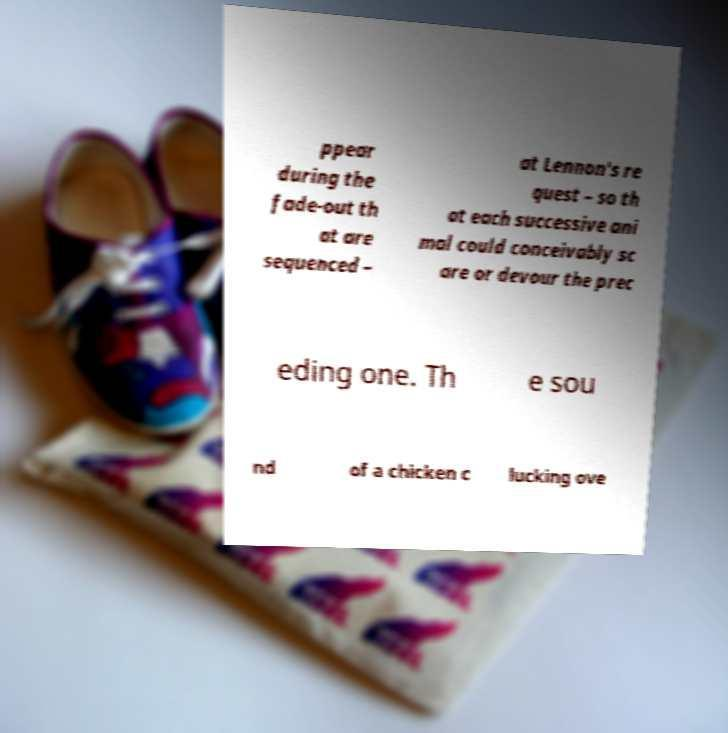For documentation purposes, I need the text within this image transcribed. Could you provide that? ppear during the fade-out th at are sequenced – at Lennon's re quest – so th at each successive ani mal could conceivably sc are or devour the prec eding one. Th e sou nd of a chicken c lucking ove 